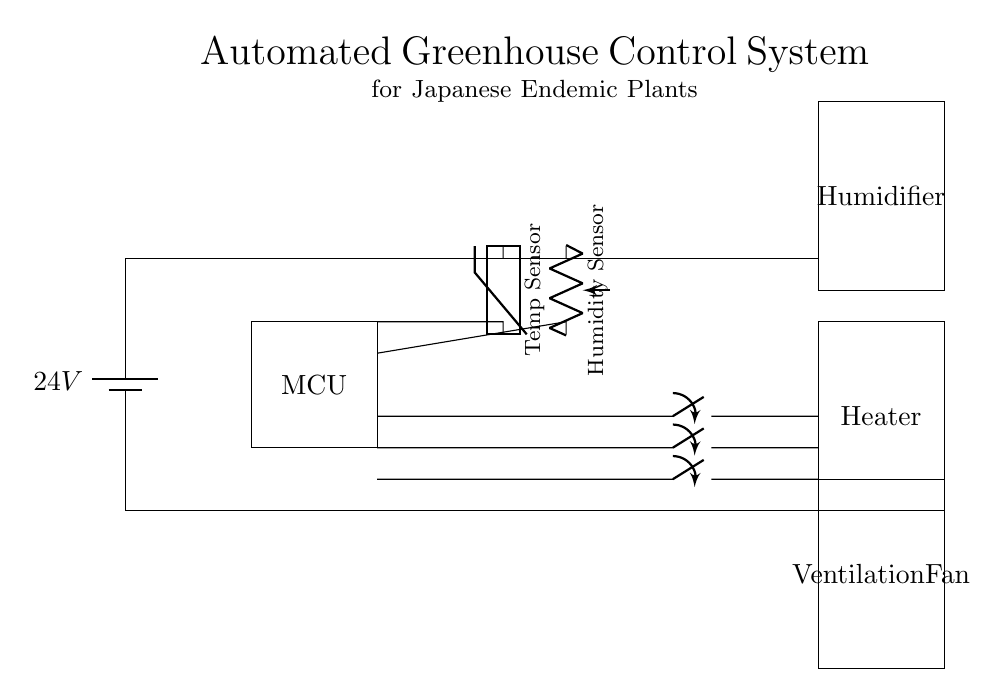What is the main power supply voltage? The circuit diagram shows a battery labeled with a voltage of 24 volts. This indicates the main power supply voltage provided to the system.
Answer: 24 volts What component is used for temperature measurement? There is a thermistor depicted in the diagram, which is a temperature sensor typically used to measure temperature changes in such systems.
Answer: Thermistor How many control switches are present in this circuit? The diagram displays three control switches for the heater, humidifier, and ventilation fan. To find the total, we count these components.
Answer: Three Which device is used to increase humidity? The circuit shows a humidifier, which is specifically designated for controlling the humidity levels in the greenhouse.
Answer: Humidifier What is the purpose of the ventilation fan? The ventilation fan in this circuit is used to regulate air circulation and temperature within the greenhouse, which helps maintain optimal conditions for plant growth.
Answer: Air circulation What connects the temperature and humidity sensors to the microcontroller? The connections from the sensors lead to the input pins of the microcontroller, allowing data from both sensors to be processed for control decisions.
Answer: Microcontroller connections Which component would turn on if the temperature is too low? In the circuit, the heater is connected with a control switch, indicating it would activate to increase temperature levels when needed.
Answer: Heater 